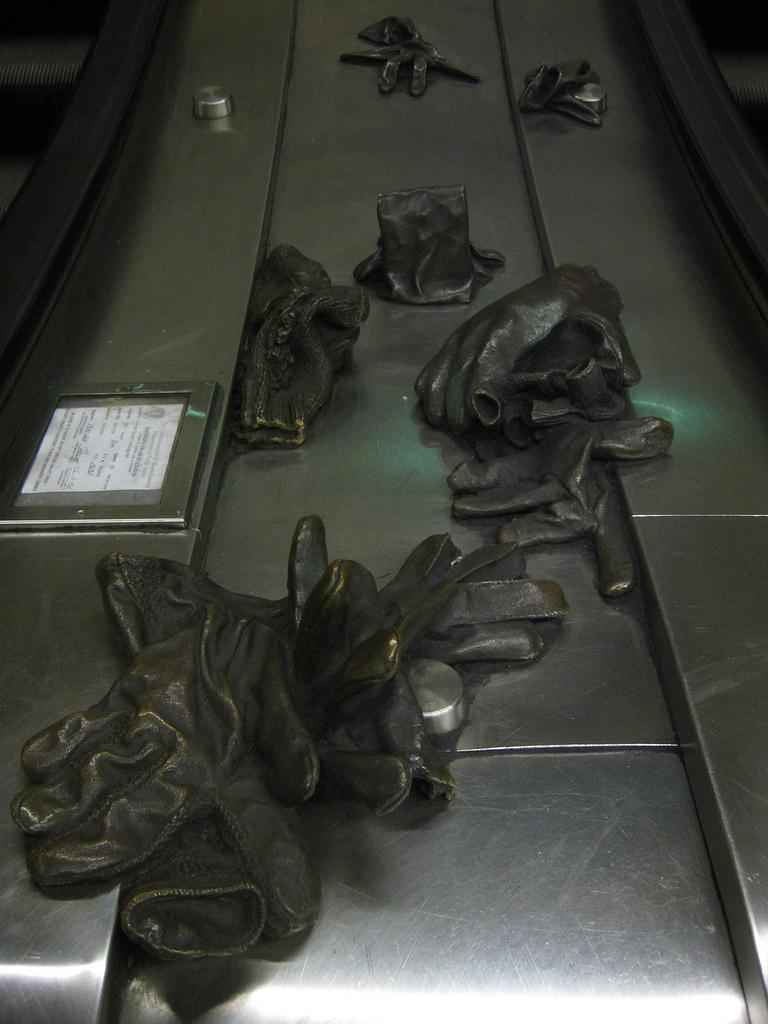What objects are on the conveyor belt in the image? There are hand gloves on a conveyor belt in the image. What can be seen on the left side of the image? There is a paper with text on the left side of the image. Where is the nest located in the image? There is no nest present in the image. What is the cause of the text on the paper in the image? The cause of the text on the paper cannot be determined from the image alone, as it may have been written or printed by various means. 